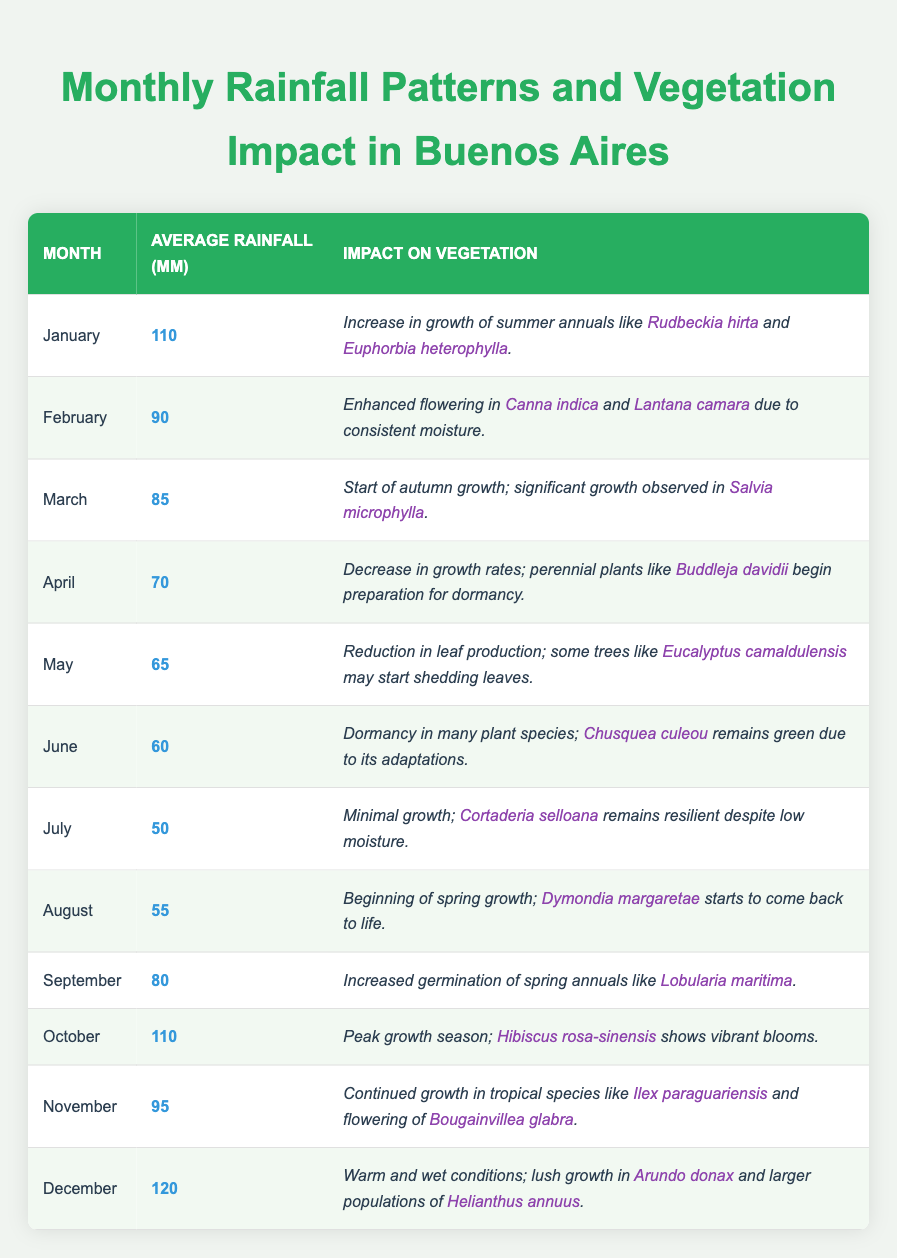What is the average rainfall in October? According to the table, the average rainfall for October is listed directly under the corresponding month. It states the average rainfall in October is 110 mm.
Answer: 110 mm In which month is the growth of *Salvia microphylla* observed? The table specifically notes that significant growth of *Salvia microphylla* is observed in March based on the information provided for that month.
Answer: March Which month reports the lowest average rainfall? By examining the average rainfall values for each month in the table, July has the lowest average rainfall of 50 mm.
Answer: July How does rainfall in December compare to January in terms of vegetation impact? The table indicates that December has 120 mm of rainfall with warm and wet conditions for lush growth in *Arundo donax* and larger populations of *Helianthus annuus*, whereas January has 110 mm of rainfall leading to an increase in growth of summer annuals like *Rudbeckia hirta* and *Euphorbia heterophylla*. December not only has more rainfall but also indicates warmer conditions supporting different species.
Answer: December has more rainfall and supports different species What is the difference in average rainfall between April and October? Referring to the table, average rainfall in April is 70 mm and in October is 110 mm. The difference is calculated as 110 mm - 70 mm = 40 mm.
Answer: 40 mm Is there a month where the impact on vegetation indicates dormancy? The table shows that June notes dormancy in many plant species, confirming that there is indeed a month (June) where this condition is recorded.
Answer: Yes, June In which two months is the rainfall above 100 mm? By checking the rainfall data, January has 110 mm and December has 120 mm, both exceeding 100 mm.
Answer: January and December Identify a month in which significant flowering occurs and its associated species. Based on the table, February is noted for enhanced flowering in *Canna indica* and *Lantana camara*, indicating significant flowering occurs during this month.
Answer: February with *Canna indica* and *Lantana camara* What pattern can be observed from rainfall during the months of November and December? November has 95 mm of average rainfall and December has 120 mm, showing an increase in rainfall from November to December, contributing to lush growth conditions identified for December.
Answer: Increasing rainfall from November to December When does the maximum flowering occur, based on average rainfall? Evaluating the table, October has peak growth season with 110 mm, showing vibrant blooms of *Hibiscus rosa-sinensis*, indicating it corresponds with significant flowering.
Answer: October 